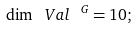<formula> <loc_0><loc_0><loc_500><loc_500>\dim \ V a l ^ { \ G } = 1 0 ;</formula> 